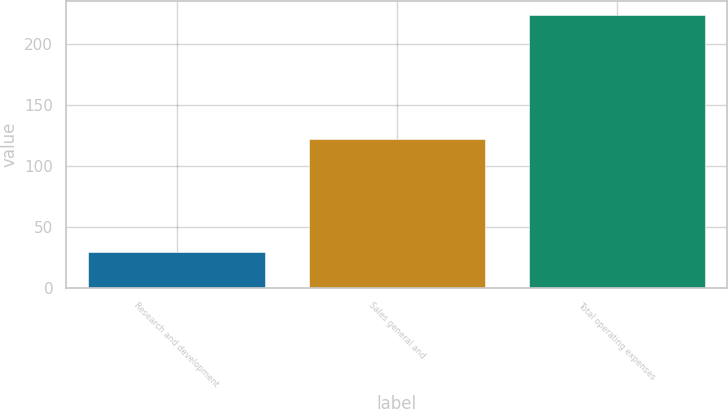Convert chart to OTSL. <chart><loc_0><loc_0><loc_500><loc_500><bar_chart><fcel>Research and development<fcel>Sales general and<fcel>Total operating expenses<nl><fcel>29<fcel>122<fcel>224<nl></chart> 